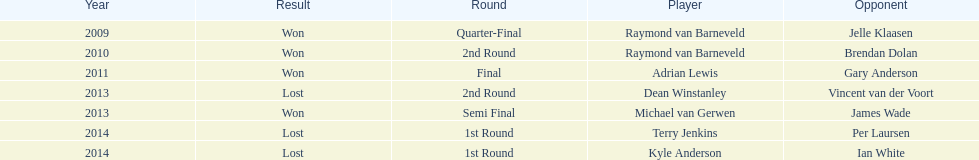Name a year with more than one game listed. 2013. 